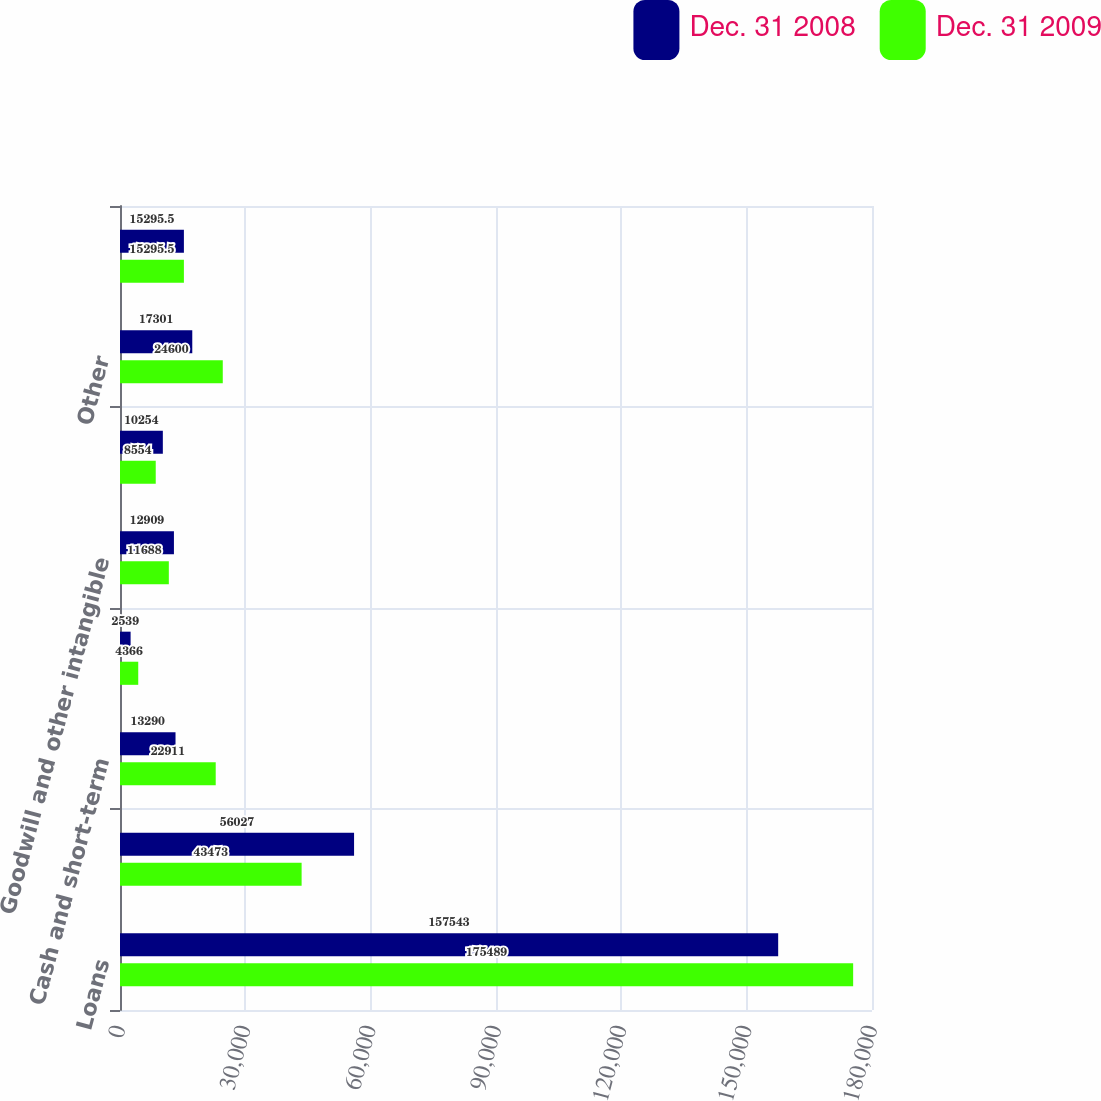Convert chart to OTSL. <chart><loc_0><loc_0><loc_500><loc_500><stacked_bar_chart><ecel><fcel>Loans<fcel>Investment securities<fcel>Cash and short-term<fcel>Loans held for sale<fcel>Goodwill and other intangible<fcel>Equity investments<fcel>Other<fcel>Total assets<nl><fcel>Dec. 31 2008<fcel>157543<fcel>56027<fcel>13290<fcel>2539<fcel>12909<fcel>10254<fcel>17301<fcel>15295.5<nl><fcel>Dec. 31 2009<fcel>175489<fcel>43473<fcel>22911<fcel>4366<fcel>11688<fcel>8554<fcel>24600<fcel>15295.5<nl></chart> 